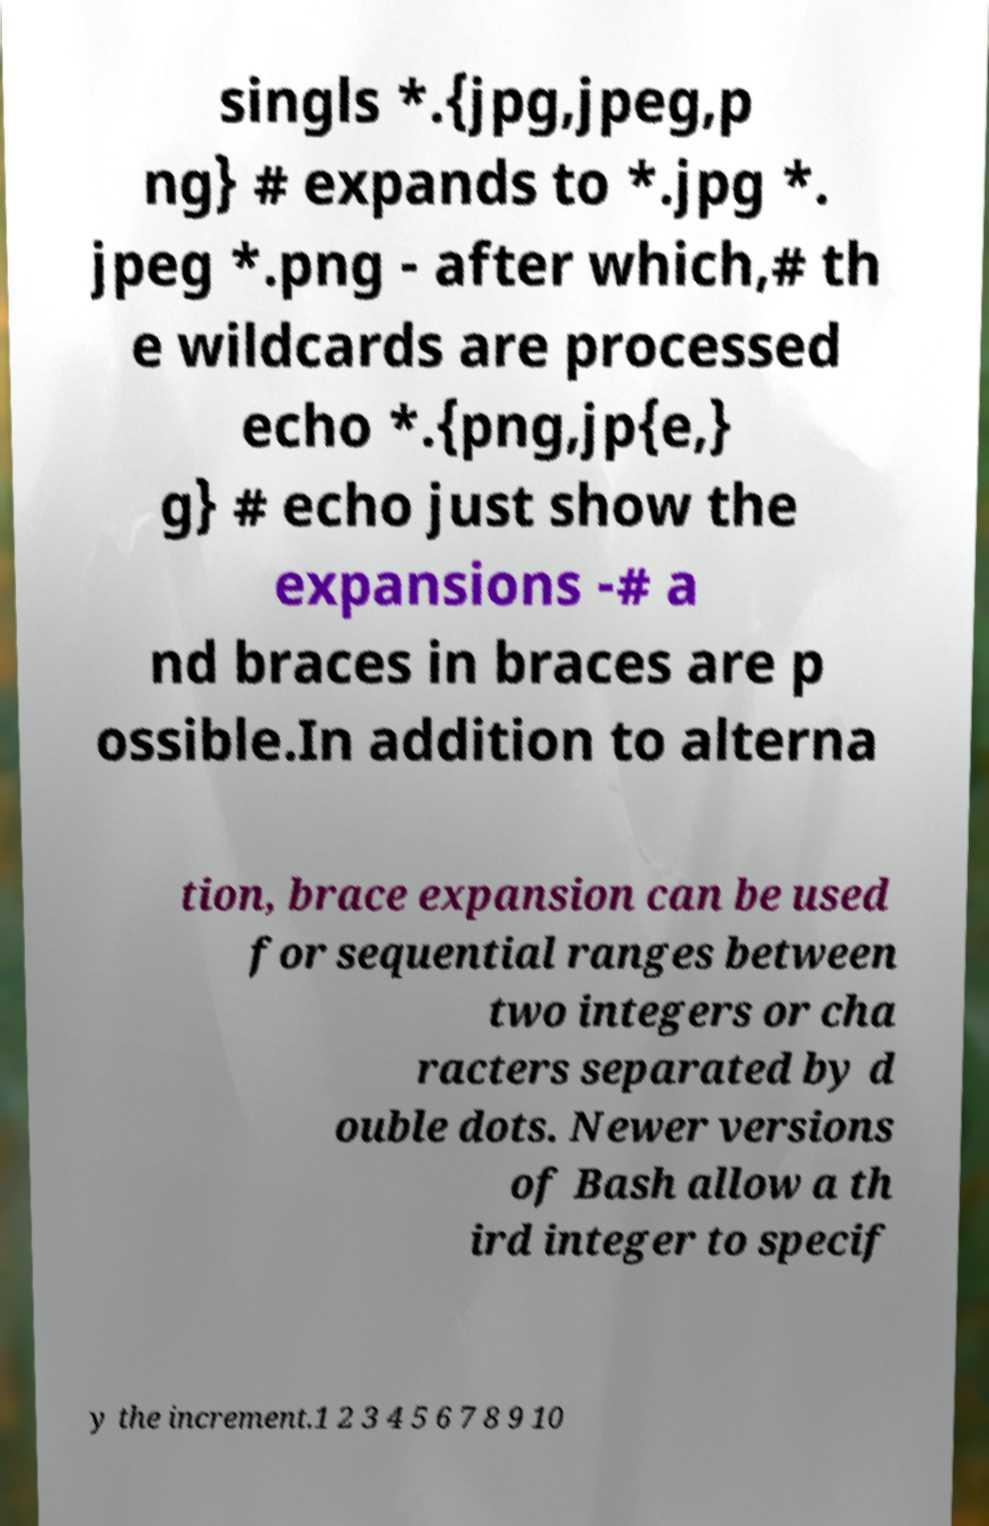Please read and relay the text visible in this image. What does it say? singls *.{jpg,jpeg,p ng} # expands to *.jpg *. jpeg *.png - after which,# th e wildcards are processed echo *.{png,jp{e,} g} # echo just show the expansions -# a nd braces in braces are p ossible.In addition to alterna tion, brace expansion can be used for sequential ranges between two integers or cha racters separated by d ouble dots. Newer versions of Bash allow a th ird integer to specif y the increment.1 2 3 4 5 6 7 8 9 10 